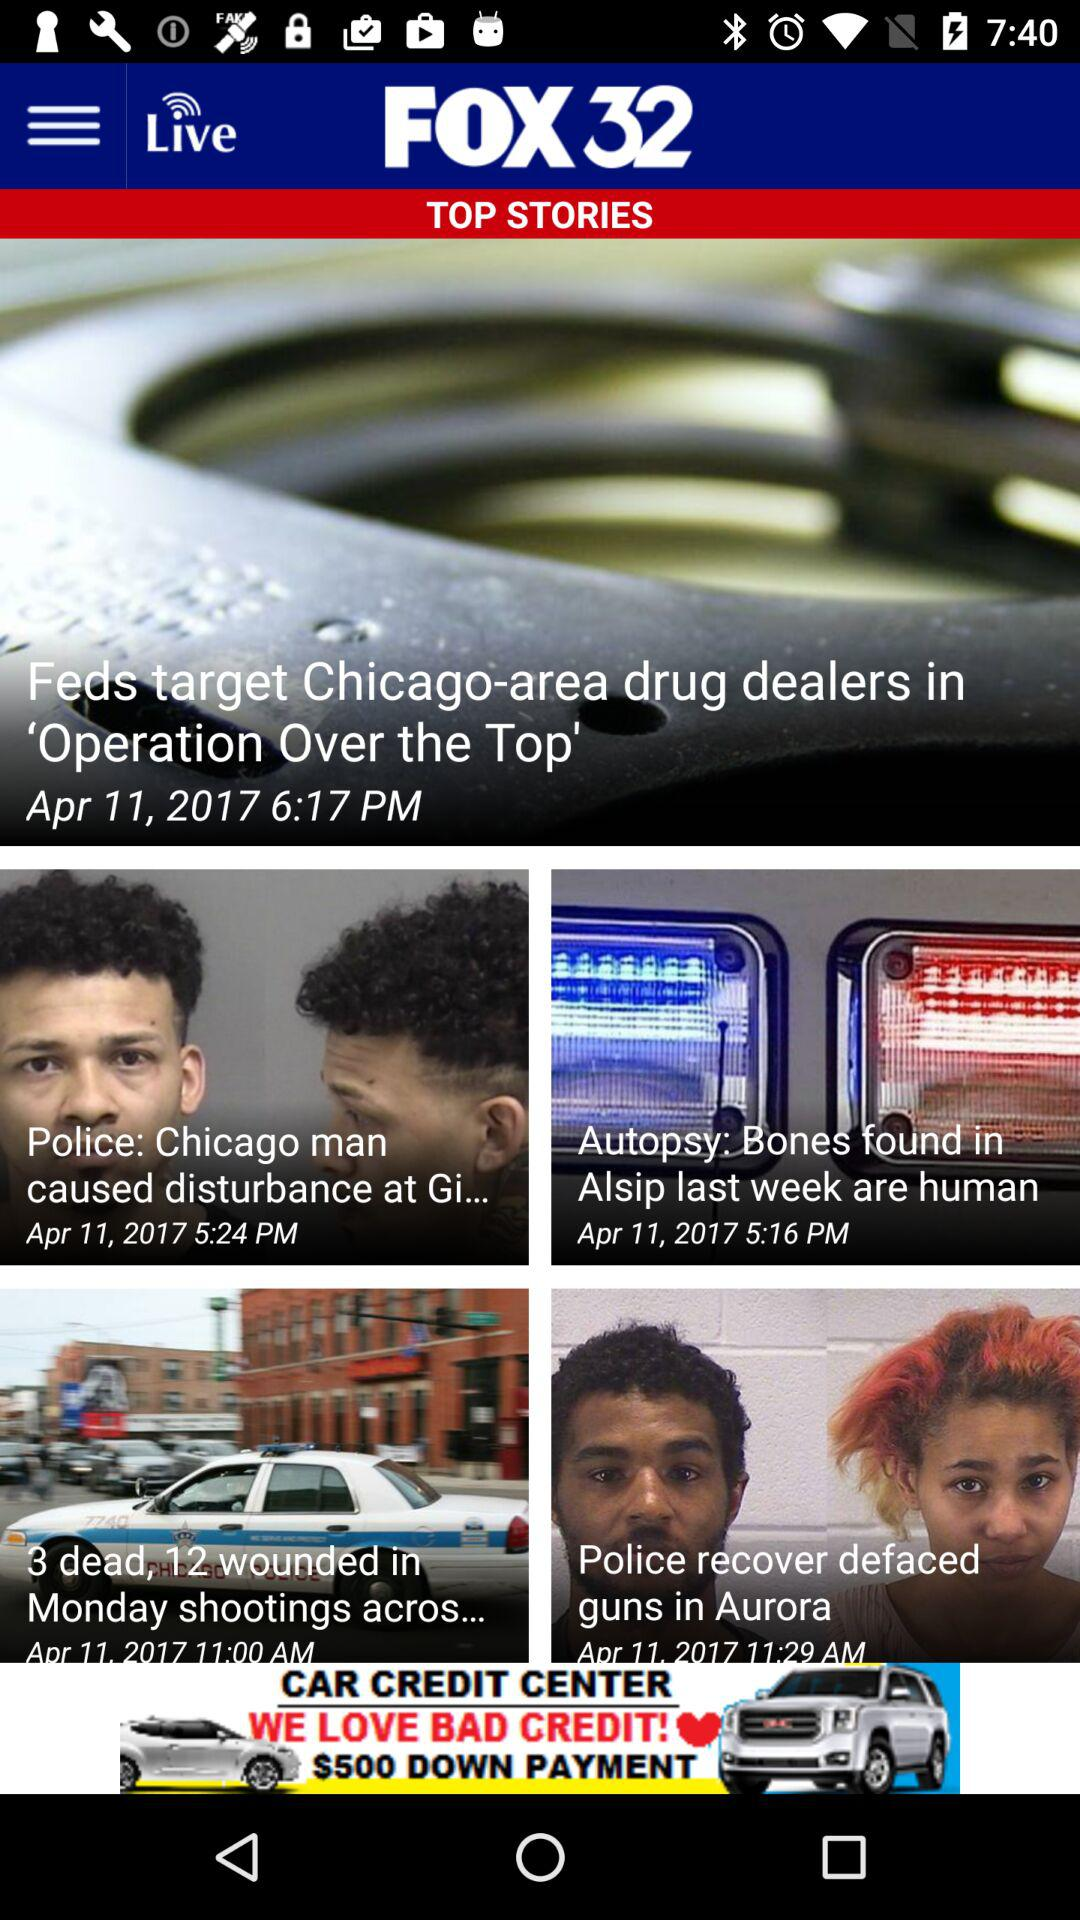What is the news channel name? The news channel name is "FOX 32". 